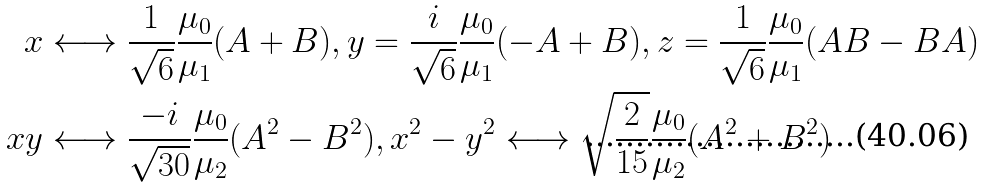<formula> <loc_0><loc_0><loc_500><loc_500>x & \longleftrightarrow \frac { 1 } { \sqrt { 6 } } \frac { \mu _ { 0 } } { \mu _ { 1 } } ( A + B ) , y = \frac { i } { \sqrt { 6 } } \frac { \mu _ { 0 } } { \mu _ { 1 } } ( - A + B ) , z = \frac { 1 } { \sqrt { 6 } } \frac { \mu _ { 0 } } { \mu _ { 1 } } ( A B - B A ) \\ x y & \longleftrightarrow \frac { - i } { \sqrt { 3 0 } } \frac { \mu _ { 0 } } { \mu _ { 2 } } ( A ^ { 2 } - B ^ { 2 } ) , x ^ { 2 } - y ^ { 2 } \longleftrightarrow \sqrt { \frac { 2 } { 1 5 } } \frac { \mu _ { 0 } } { \mu _ { 2 } } ( A ^ { 2 } + B ^ { 2 } )</formula> 